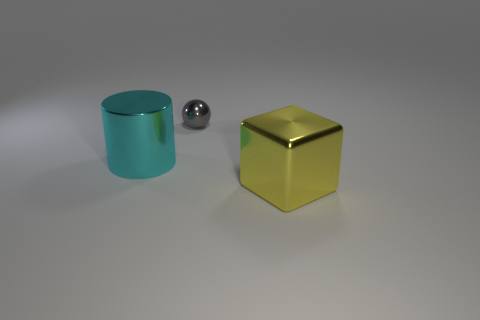Add 2 large green things. How many objects exist? 5 Subtract all cubes. How many objects are left? 2 Add 2 yellow cubes. How many yellow cubes are left? 3 Add 3 green rubber spheres. How many green rubber spheres exist? 3 Subtract 0 green blocks. How many objects are left? 3 Subtract all large yellow blocks. Subtract all tiny spheres. How many objects are left? 1 